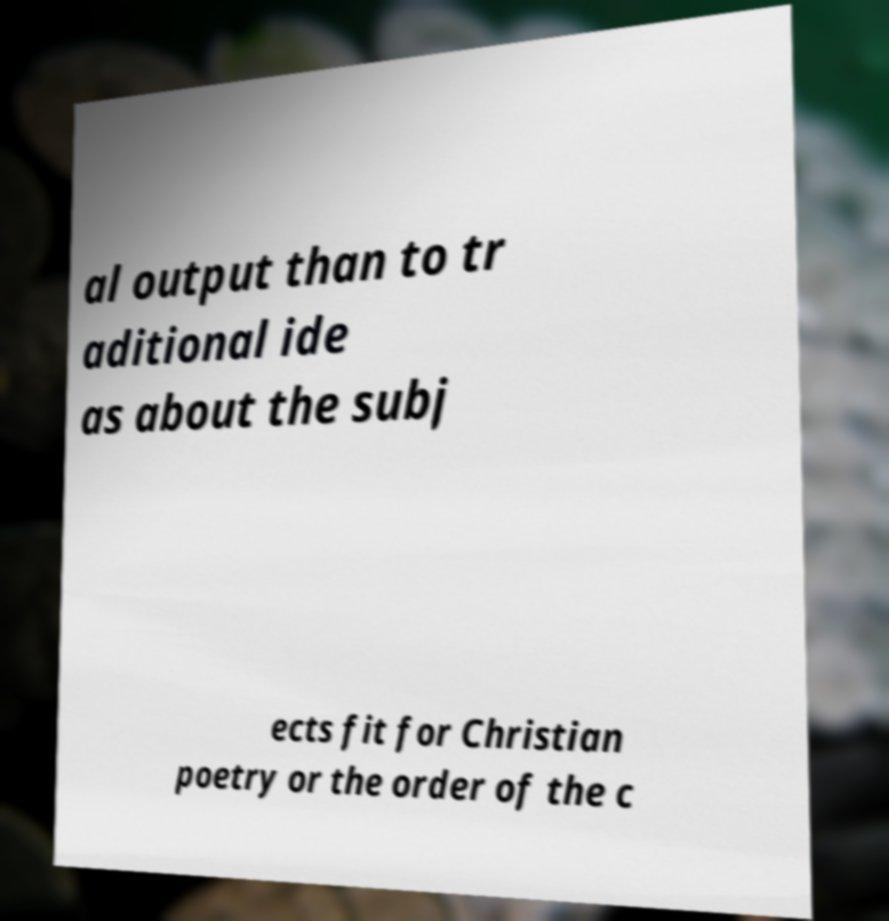Please identify and transcribe the text found in this image. al output than to tr aditional ide as about the subj ects fit for Christian poetry or the order of the c 